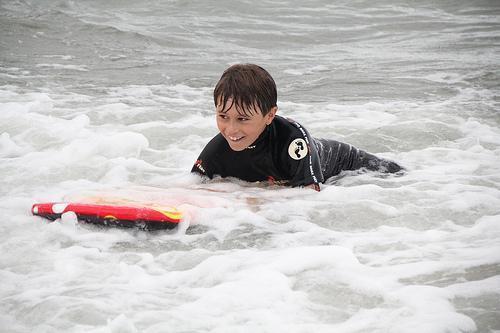How many boys are there?
Give a very brief answer. 1. 